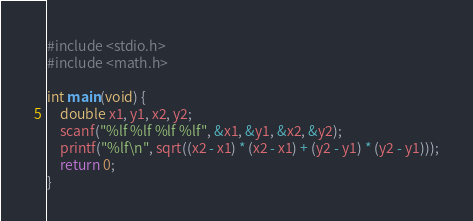<code> <loc_0><loc_0><loc_500><loc_500><_C_>#include <stdio.h>
#include <math.h>

int main(void) {
	double x1, y1, x2, y2;
	scanf("%lf %lf %lf %lf", &x1, &y1, &x2, &y2);
	printf("%lf\n", sqrt((x2 - x1) * (x2 - x1) + (y2 - y1) * (y2 - y1)));
	return 0;
}</code> 